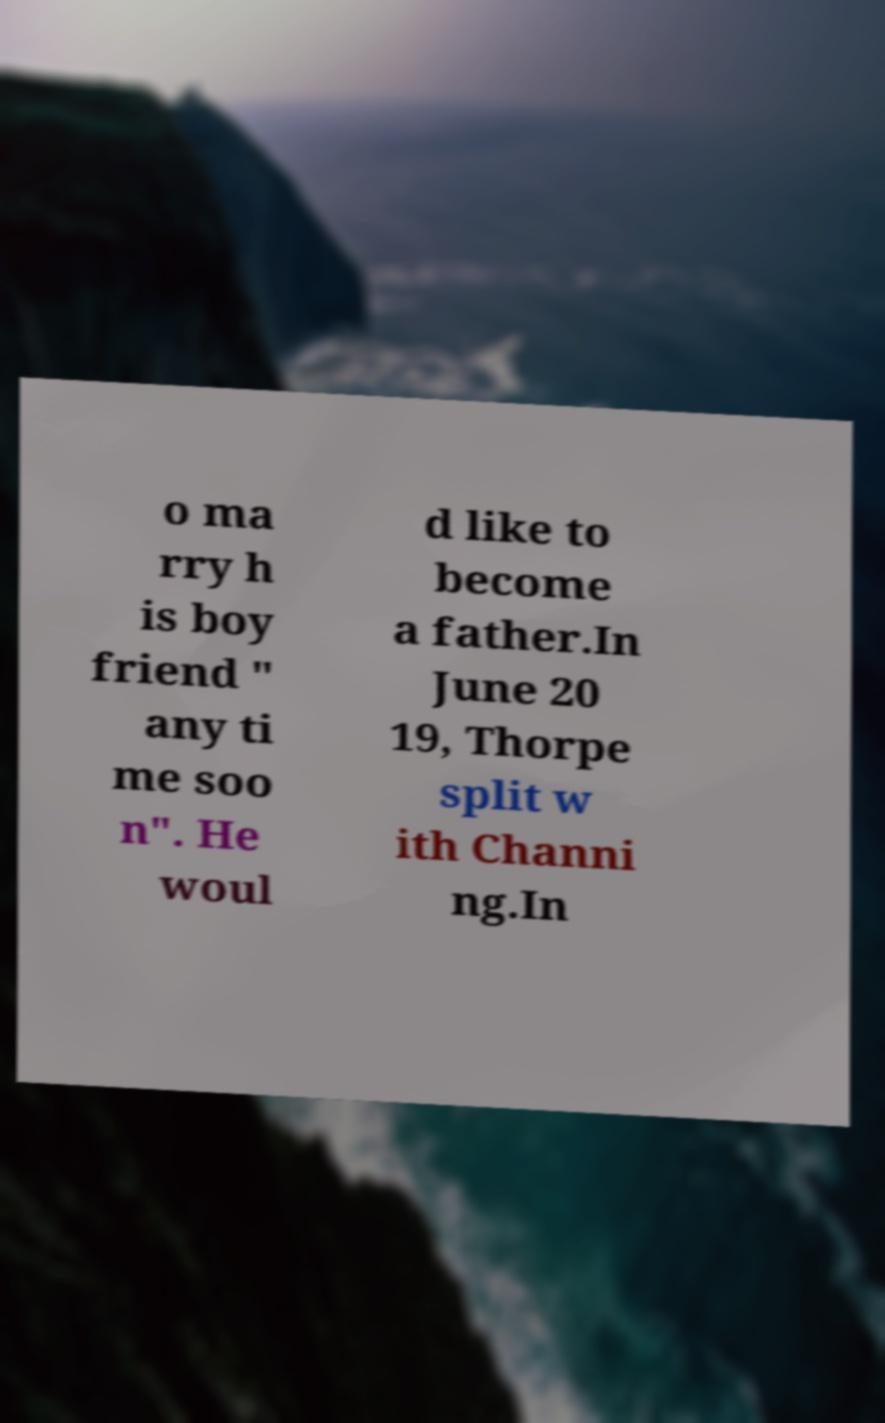Please read and relay the text visible in this image. What does it say? o ma rry h is boy friend " any ti me soo n". He woul d like to become a father.In June 20 19, Thorpe split w ith Channi ng.In 